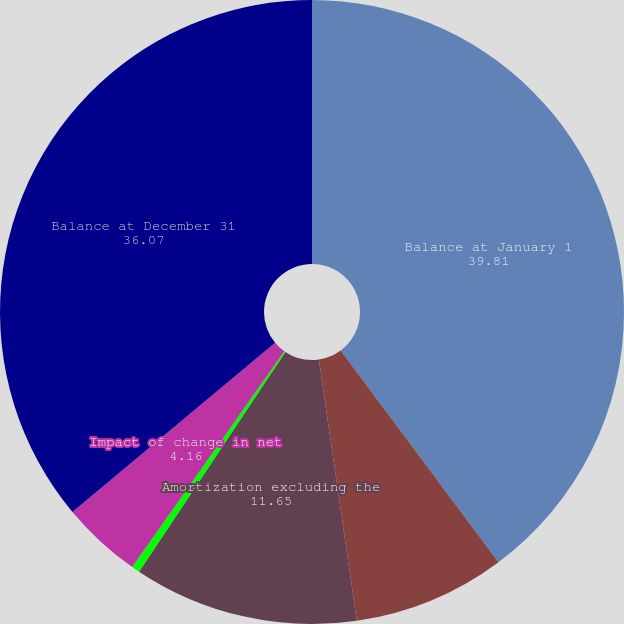<chart> <loc_0><loc_0><loc_500><loc_500><pie_chart><fcel>Balance at January 1<fcel>Capitalization of acquisition<fcel>Amortization excluding the<fcel>Amortization impact of<fcel>Impact of change in net<fcel>Balance at December 31<nl><fcel>39.81%<fcel>7.9%<fcel>11.65%<fcel>0.42%<fcel>4.16%<fcel>36.07%<nl></chart> 